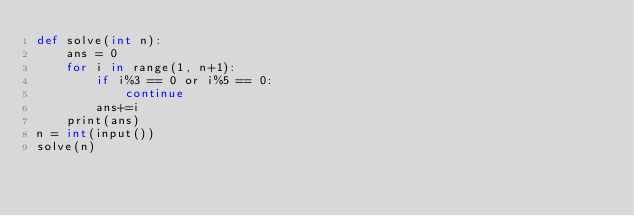Convert code to text. <code><loc_0><loc_0><loc_500><loc_500><_Cython_>def solve(int n):
    ans = 0
    for i in range(1, n+1):
        if i%3 == 0 or i%5 == 0:
            continue
        ans+=i
    print(ans)
n = int(input())
solve(n)</code> 